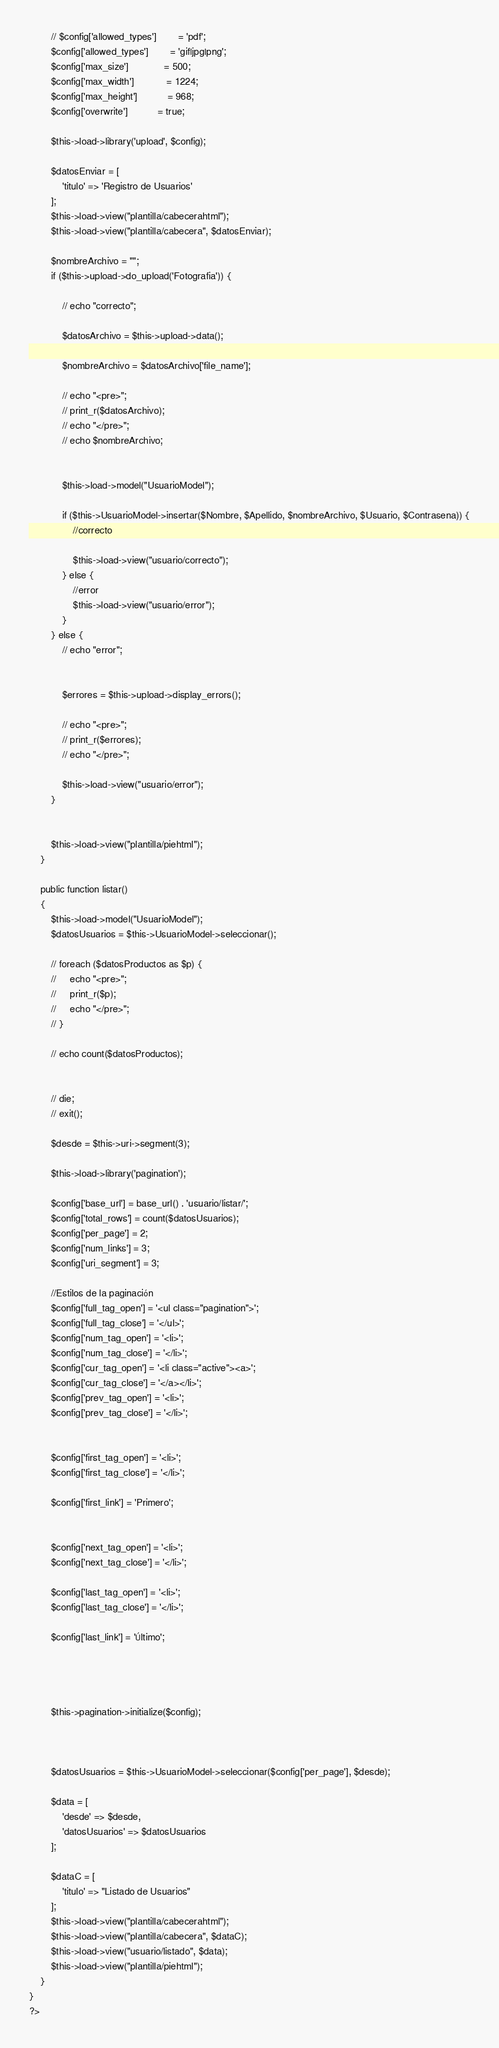<code> <loc_0><loc_0><loc_500><loc_500><_PHP_>        // $config['allowed_types']        = 'pdf';
        $config['allowed_types']        = 'gif|jpg|png';
        $config['max_size']             = 500;
        $config['max_width']            = 1224;
        $config['max_height']           = 968;
        $config['overwrite']           = true;

        $this->load->library('upload', $config);

        $datosEnviar = [
            'titulo' => 'Registro de Usuarios'
        ];
        $this->load->view("plantilla/cabecerahtml");
        $this->load->view("plantilla/cabecera", $datosEnviar);

        $nombreArchivo = "";
        if ($this->upload->do_upload('Fotografia')) {

            // echo "correcto";

            $datosArchivo = $this->upload->data();

            $nombreArchivo = $datosArchivo['file_name'];

            // echo "<pre>";
            // print_r($datosArchivo);
            // echo "</pre>";
            // echo $nombreArchivo;


            $this->load->model("UsuarioModel");

            if ($this->UsuarioModel->insertar($Nombre, $Apellido, $nombreArchivo, $Usuario, $Contrasena)) {
                //correcto

                $this->load->view("usuario/correcto");
            } else {
                //error
                $this->load->view("usuario/error");
            }
        } else {
            // echo "error";


            $errores = $this->upload->display_errors();

            // echo "<pre>";
            // print_r($errores);
            // echo "</pre>";

            $this->load->view("usuario/error");
        }


        $this->load->view("plantilla/piehtml");
    }

    public function listar()
    {
        $this->load->model("UsuarioModel");
        $datosUsuarios = $this->UsuarioModel->seleccionar();

        // foreach ($datosProductos as $p) {
        //     echo "<pre>";
        //     print_r($p);
        //     echo "</pre>";
        // }

        // echo count($datosProductos);


        // die;
        // exit();

        $desde = $this->uri->segment(3);

        $this->load->library('pagination');

        $config['base_url'] = base_url() . 'usuario/listar/';
        $config['total_rows'] = count($datosUsuarios);
        $config['per_page'] = 2;
        $config['num_links'] = 3;
        $config['uri_segment'] = 3;

        //Estilos de la paginación
        $config['full_tag_open'] = '<ul class="pagination">';
        $config['full_tag_close'] = '</ul>';
        $config['num_tag_open'] = '<li>';
        $config['num_tag_close'] = '</li>';
        $config['cur_tag_open'] = '<li class="active"><a>';
        $config['cur_tag_close'] = '</a></li>';
        $config['prev_tag_open'] = '<li>';
        $config['prev_tag_close'] = '</li>';


        $config['first_tag_open'] = '<li>';
        $config['first_tag_close'] = '</li>';

        $config['first_link'] = 'Primero';


        $config['next_tag_open'] = '<li>';
        $config['next_tag_close'] = '</li>';

        $config['last_tag_open'] = '<li>';
        $config['last_tag_close'] = '</li>';

        $config['last_link'] = 'Último';




        $this->pagination->initialize($config);



        $datosUsuarios = $this->UsuarioModel->seleccionar($config['per_page'], $desde);

        $data = [
            'desde' => $desde,
            'datosUsuarios' => $datosUsuarios
        ];

        $dataC = [
            'titulo' => "Listado de Usuarios"
        ];
        $this->load->view("plantilla/cabecerahtml");
        $this->load->view("plantilla/cabecera", $dataC);
        $this->load->view("usuario/listado", $data);
        $this->load->view("plantilla/piehtml");
    }
}
?></code> 